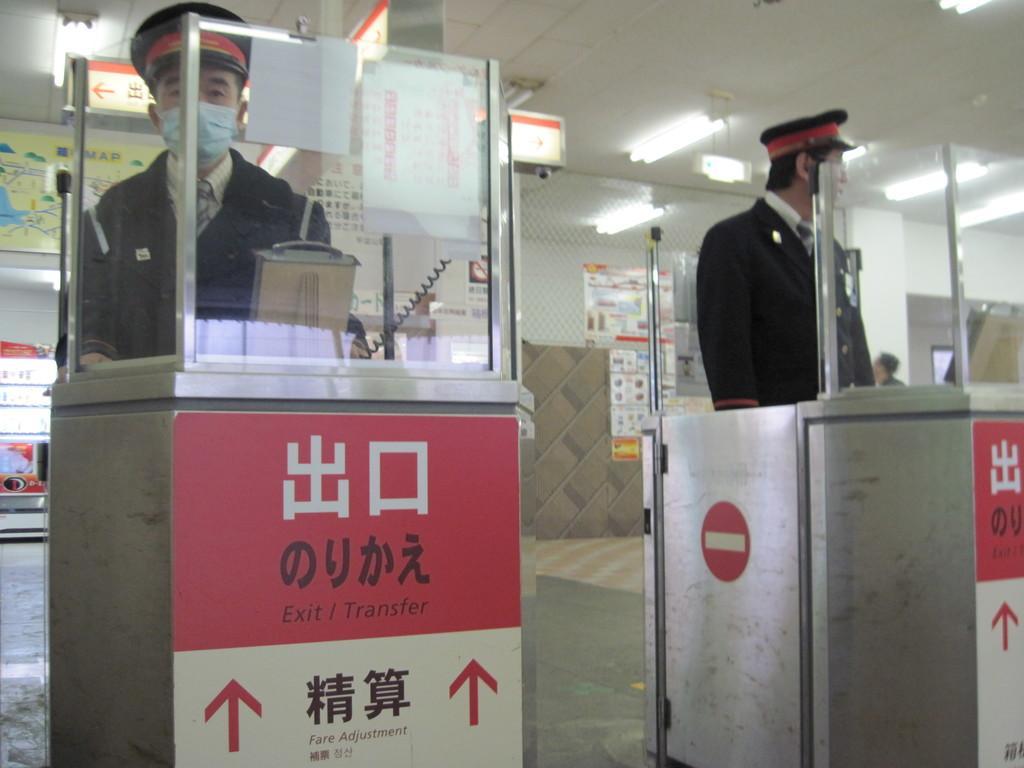Can you describe this image briefly? In this image I can see a person standing wearing black color dress and I can also see the other person standing, in front I can see a glass frame. Background I can see few papers attached to the wall and I can also see few lights. 